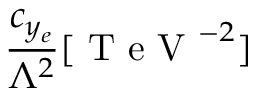<formula> <loc_0><loc_0><loc_500><loc_500>\frac { c _ { y _ { e } } } { \Lambda ^ { 2 } } [ T e V ^ { - 2 } ]</formula> 